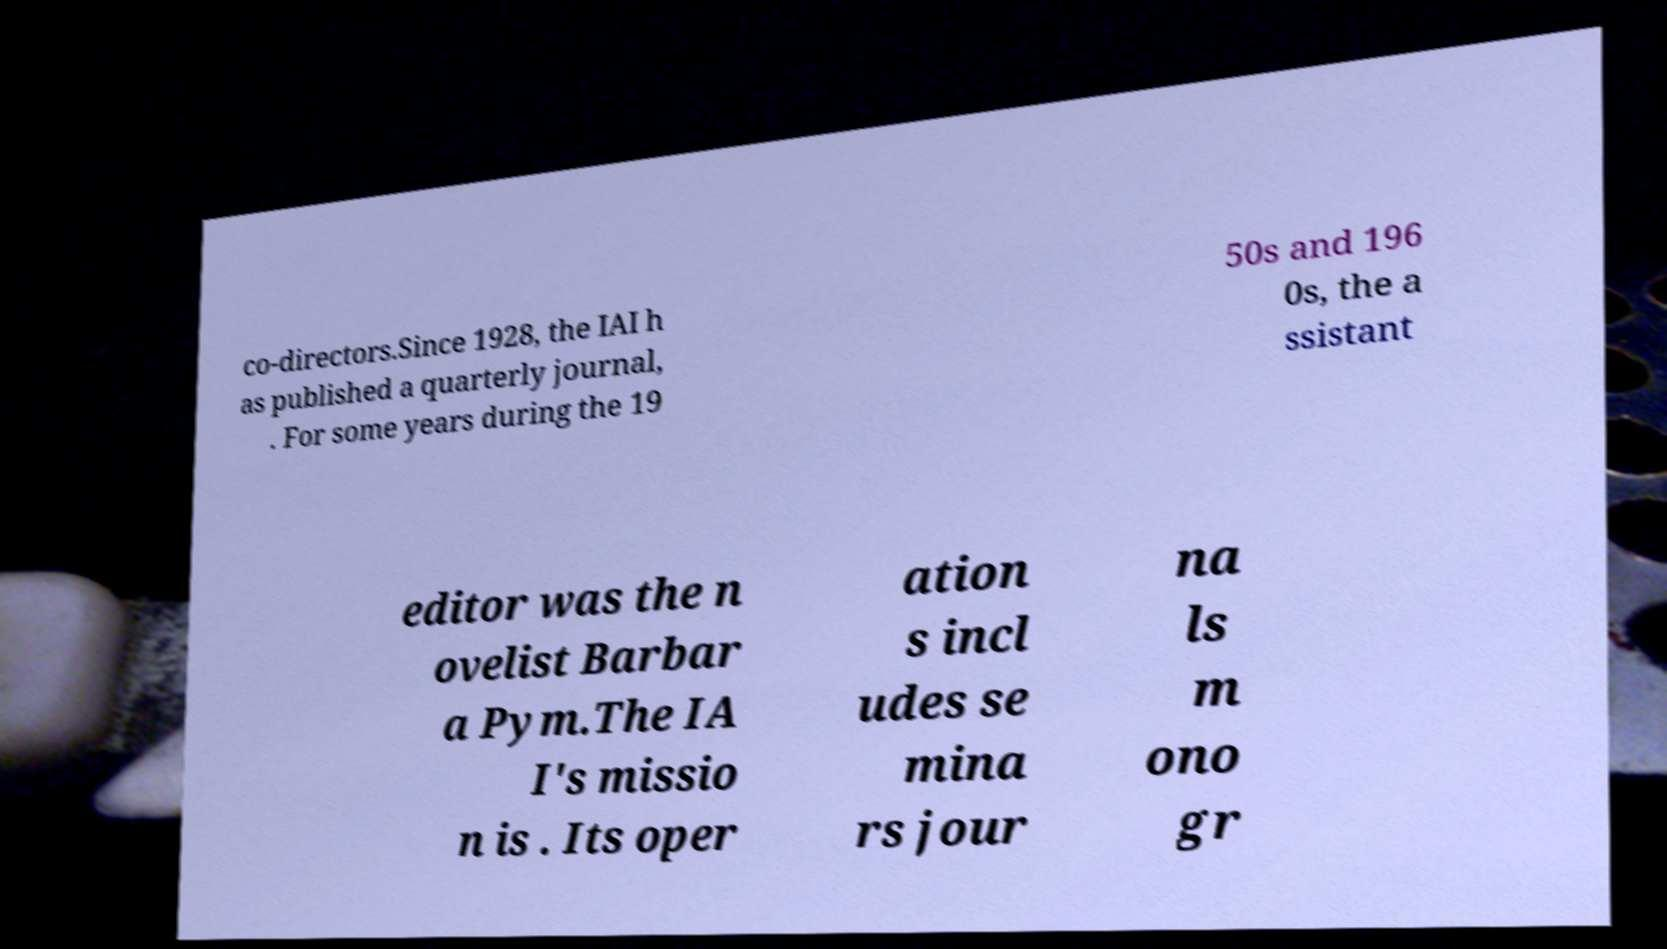Could you assist in decoding the text presented in this image and type it out clearly? co-directors.Since 1928, the IAI h as published a quarterly journal, . For some years during the 19 50s and 196 0s, the a ssistant editor was the n ovelist Barbar a Pym.The IA I's missio n is . Its oper ation s incl udes se mina rs jour na ls m ono gr 